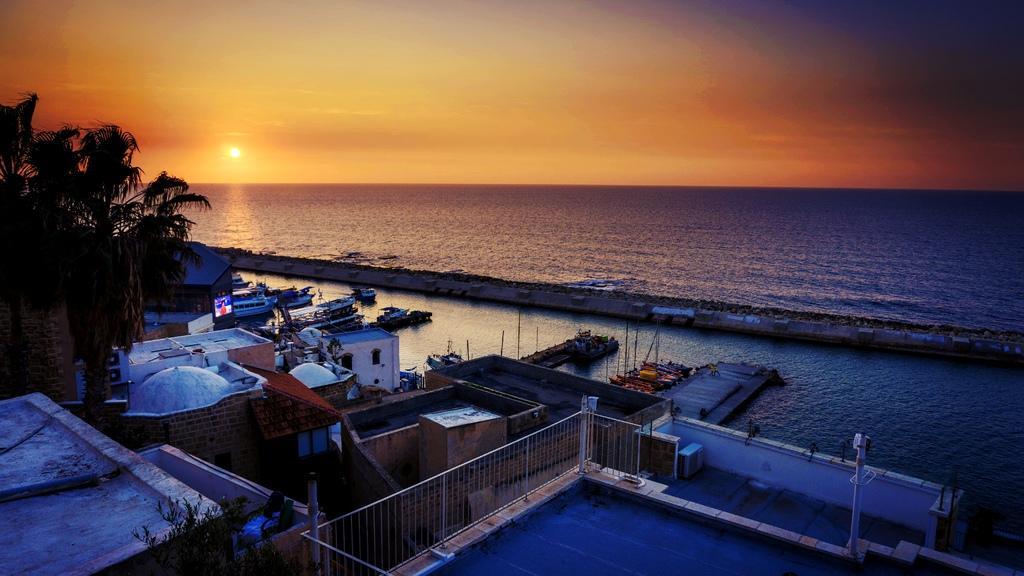In one or two sentences, can you explain what this image depicts? In the picture I can see the ocean. I can see the sunshine and the clouds in the sky. I can see the boats in the water. There are buildings on the side of the ocean. There are trees on the left side. 